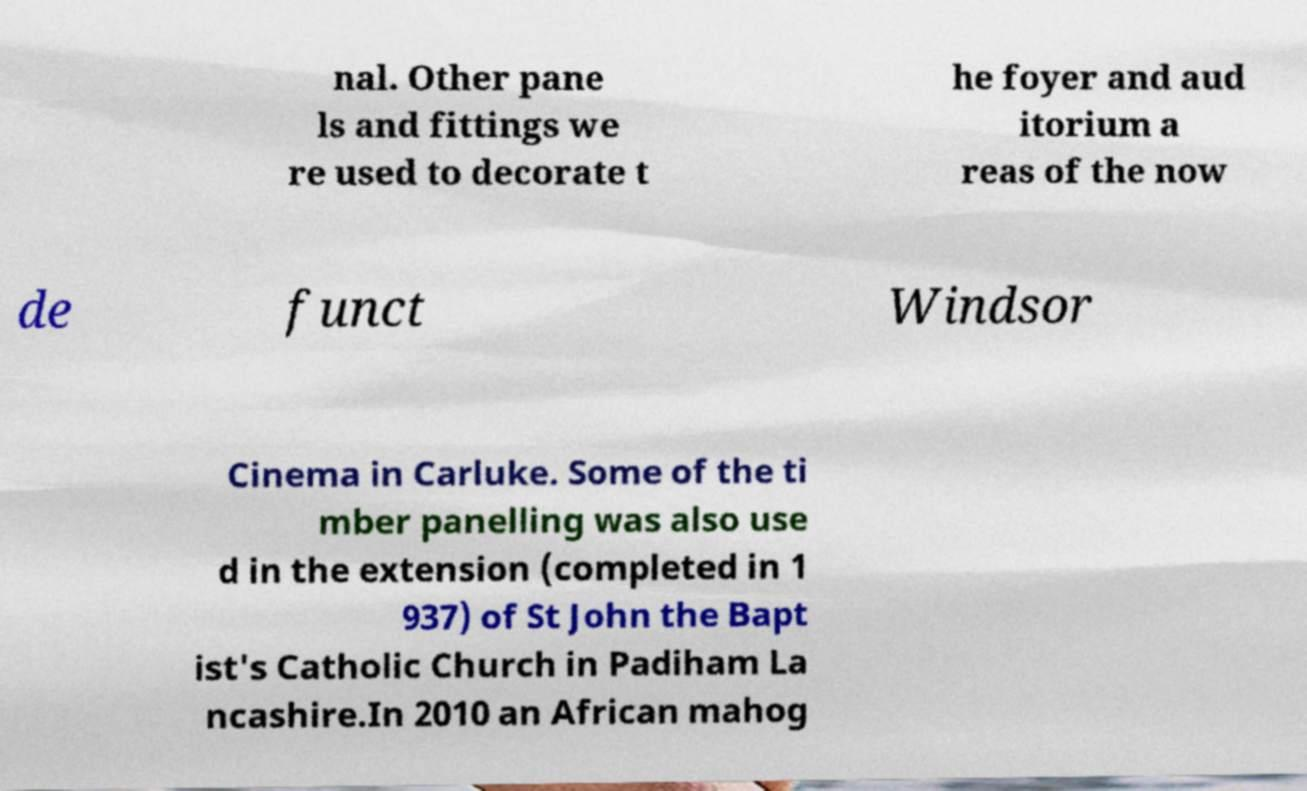Could you assist in decoding the text presented in this image and type it out clearly? nal. Other pane ls and fittings we re used to decorate t he foyer and aud itorium a reas of the now de funct Windsor Cinema in Carluke. Some of the ti mber panelling was also use d in the extension (completed in 1 937) of St John the Bapt ist's Catholic Church in Padiham La ncashire.In 2010 an African mahog 